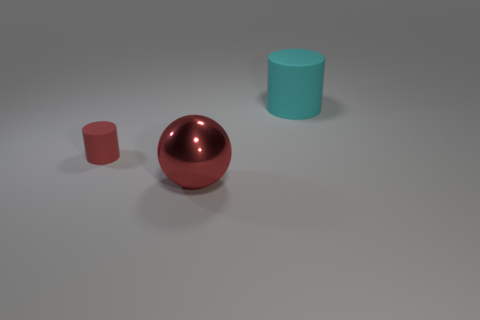Add 2 large gray spheres. How many objects exist? 5 Subtract all cylinders. How many objects are left? 1 Subtract all big yellow spheres. Subtract all tiny red cylinders. How many objects are left? 2 Add 2 large metallic things. How many large metallic things are left? 3 Add 2 small cubes. How many small cubes exist? 2 Subtract 1 red balls. How many objects are left? 2 